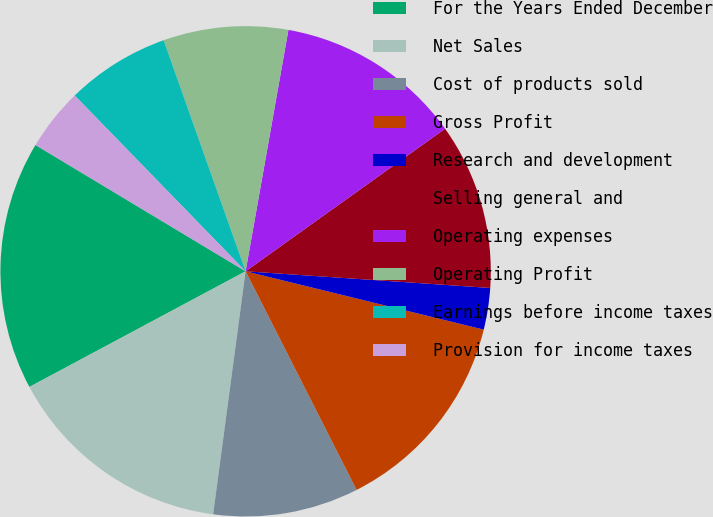Convert chart. <chart><loc_0><loc_0><loc_500><loc_500><pie_chart><fcel>For the Years Ended December<fcel>Net Sales<fcel>Cost of products sold<fcel>Gross Profit<fcel>Research and development<fcel>Selling general and<fcel>Operating expenses<fcel>Operating Profit<fcel>Earnings before income taxes<fcel>Provision for income taxes<nl><fcel>16.43%<fcel>15.07%<fcel>9.59%<fcel>13.7%<fcel>2.74%<fcel>10.96%<fcel>12.33%<fcel>8.22%<fcel>6.85%<fcel>4.11%<nl></chart> 